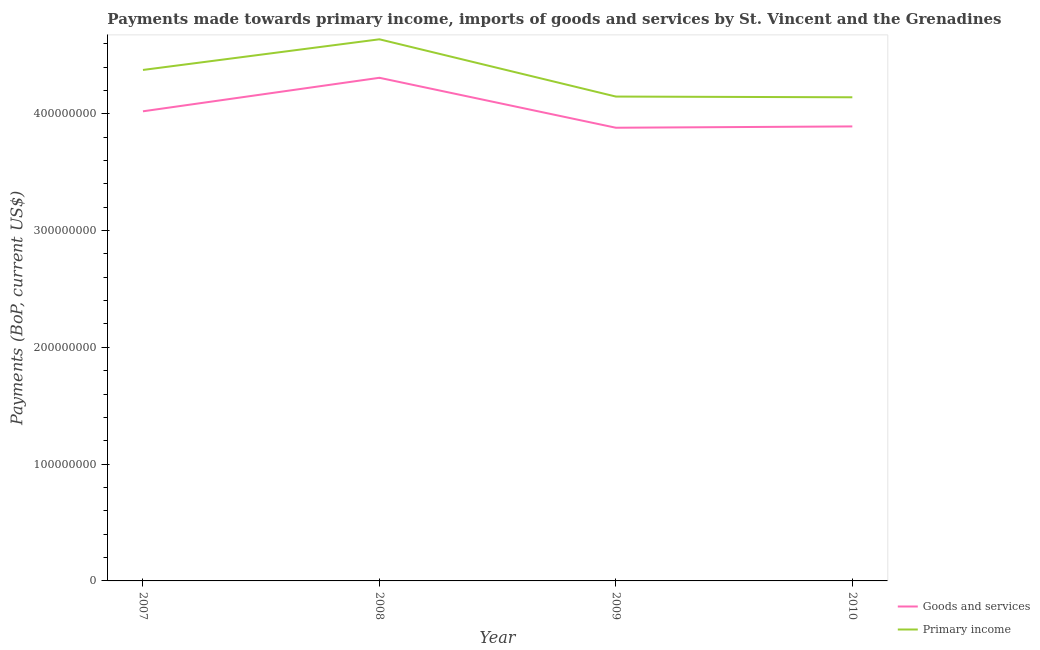How many different coloured lines are there?
Provide a succinct answer. 2. What is the payments made towards primary income in 2007?
Ensure brevity in your answer.  4.38e+08. Across all years, what is the maximum payments made towards primary income?
Give a very brief answer. 4.64e+08. Across all years, what is the minimum payments made towards primary income?
Give a very brief answer. 4.14e+08. In which year was the payments made towards goods and services maximum?
Provide a succinct answer. 2008. In which year was the payments made towards primary income minimum?
Provide a succinct answer. 2010. What is the total payments made towards primary income in the graph?
Provide a succinct answer. 1.73e+09. What is the difference between the payments made towards primary income in 2009 and that in 2010?
Give a very brief answer. 6.12e+05. What is the difference between the payments made towards primary income in 2009 and the payments made towards goods and services in 2008?
Provide a succinct answer. -1.61e+07. What is the average payments made towards goods and services per year?
Offer a very short reply. 4.03e+08. In the year 2007, what is the difference between the payments made towards goods and services and payments made towards primary income?
Ensure brevity in your answer.  -3.54e+07. What is the ratio of the payments made towards primary income in 2007 to that in 2008?
Offer a very short reply. 0.94. Is the payments made towards goods and services in 2007 less than that in 2010?
Give a very brief answer. No. Is the difference between the payments made towards primary income in 2008 and 2009 greater than the difference between the payments made towards goods and services in 2008 and 2009?
Ensure brevity in your answer.  Yes. What is the difference between the highest and the second highest payments made towards goods and services?
Offer a terse response. 2.87e+07. What is the difference between the highest and the lowest payments made towards primary income?
Ensure brevity in your answer.  4.96e+07. In how many years, is the payments made towards primary income greater than the average payments made towards primary income taken over all years?
Keep it short and to the point. 2. Is the sum of the payments made towards primary income in 2008 and 2009 greater than the maximum payments made towards goods and services across all years?
Your answer should be very brief. Yes. Does the payments made towards goods and services monotonically increase over the years?
Offer a terse response. No. Is the payments made towards primary income strictly greater than the payments made towards goods and services over the years?
Make the answer very short. Yes. Is the payments made towards goods and services strictly less than the payments made towards primary income over the years?
Keep it short and to the point. Yes. How many lines are there?
Provide a succinct answer. 2. How many years are there in the graph?
Keep it short and to the point. 4. Are the values on the major ticks of Y-axis written in scientific E-notation?
Your answer should be compact. No. Does the graph contain any zero values?
Give a very brief answer. No. Where does the legend appear in the graph?
Your answer should be very brief. Bottom right. How many legend labels are there?
Your answer should be compact. 2. What is the title of the graph?
Offer a very short reply. Payments made towards primary income, imports of goods and services by St. Vincent and the Grenadines. Does "Total Population" appear as one of the legend labels in the graph?
Your answer should be compact. No. What is the label or title of the Y-axis?
Make the answer very short. Payments (BoP, current US$). What is the Payments (BoP, current US$) of Goods and services in 2007?
Give a very brief answer. 4.02e+08. What is the Payments (BoP, current US$) of Primary income in 2007?
Provide a short and direct response. 4.38e+08. What is the Payments (BoP, current US$) in Goods and services in 2008?
Your answer should be compact. 4.31e+08. What is the Payments (BoP, current US$) of Primary income in 2008?
Offer a very short reply. 4.64e+08. What is the Payments (BoP, current US$) of Goods and services in 2009?
Provide a succinct answer. 3.88e+08. What is the Payments (BoP, current US$) of Primary income in 2009?
Give a very brief answer. 4.15e+08. What is the Payments (BoP, current US$) of Goods and services in 2010?
Provide a short and direct response. 3.89e+08. What is the Payments (BoP, current US$) in Primary income in 2010?
Offer a terse response. 4.14e+08. Across all years, what is the maximum Payments (BoP, current US$) of Goods and services?
Ensure brevity in your answer.  4.31e+08. Across all years, what is the maximum Payments (BoP, current US$) in Primary income?
Your answer should be very brief. 4.64e+08. Across all years, what is the minimum Payments (BoP, current US$) in Goods and services?
Keep it short and to the point. 3.88e+08. Across all years, what is the minimum Payments (BoP, current US$) in Primary income?
Make the answer very short. 4.14e+08. What is the total Payments (BoP, current US$) in Goods and services in the graph?
Provide a succinct answer. 1.61e+09. What is the total Payments (BoP, current US$) of Primary income in the graph?
Make the answer very short. 1.73e+09. What is the difference between the Payments (BoP, current US$) in Goods and services in 2007 and that in 2008?
Offer a terse response. -2.87e+07. What is the difference between the Payments (BoP, current US$) in Primary income in 2007 and that in 2008?
Offer a terse response. -2.62e+07. What is the difference between the Payments (BoP, current US$) of Goods and services in 2007 and that in 2009?
Offer a terse response. 1.41e+07. What is the difference between the Payments (BoP, current US$) in Primary income in 2007 and that in 2009?
Give a very brief answer. 2.28e+07. What is the difference between the Payments (BoP, current US$) in Goods and services in 2007 and that in 2010?
Provide a short and direct response. 1.29e+07. What is the difference between the Payments (BoP, current US$) of Primary income in 2007 and that in 2010?
Ensure brevity in your answer.  2.34e+07. What is the difference between the Payments (BoP, current US$) in Goods and services in 2008 and that in 2009?
Offer a very short reply. 4.28e+07. What is the difference between the Payments (BoP, current US$) in Primary income in 2008 and that in 2009?
Your answer should be compact. 4.90e+07. What is the difference between the Payments (BoP, current US$) in Goods and services in 2008 and that in 2010?
Make the answer very short. 4.16e+07. What is the difference between the Payments (BoP, current US$) in Primary income in 2008 and that in 2010?
Your answer should be compact. 4.96e+07. What is the difference between the Payments (BoP, current US$) in Goods and services in 2009 and that in 2010?
Keep it short and to the point. -1.13e+06. What is the difference between the Payments (BoP, current US$) in Primary income in 2009 and that in 2010?
Offer a terse response. 6.12e+05. What is the difference between the Payments (BoP, current US$) in Goods and services in 2007 and the Payments (BoP, current US$) in Primary income in 2008?
Provide a short and direct response. -6.17e+07. What is the difference between the Payments (BoP, current US$) in Goods and services in 2007 and the Payments (BoP, current US$) in Primary income in 2009?
Provide a short and direct response. -1.26e+07. What is the difference between the Payments (BoP, current US$) of Goods and services in 2007 and the Payments (BoP, current US$) of Primary income in 2010?
Keep it short and to the point. -1.20e+07. What is the difference between the Payments (BoP, current US$) of Goods and services in 2008 and the Payments (BoP, current US$) of Primary income in 2009?
Ensure brevity in your answer.  1.61e+07. What is the difference between the Payments (BoP, current US$) in Goods and services in 2008 and the Payments (BoP, current US$) in Primary income in 2010?
Ensure brevity in your answer.  1.67e+07. What is the difference between the Payments (BoP, current US$) in Goods and services in 2009 and the Payments (BoP, current US$) in Primary income in 2010?
Offer a very short reply. -2.61e+07. What is the average Payments (BoP, current US$) of Goods and services per year?
Your answer should be very brief. 4.03e+08. What is the average Payments (BoP, current US$) in Primary income per year?
Provide a succinct answer. 4.33e+08. In the year 2007, what is the difference between the Payments (BoP, current US$) in Goods and services and Payments (BoP, current US$) in Primary income?
Offer a terse response. -3.54e+07. In the year 2008, what is the difference between the Payments (BoP, current US$) in Goods and services and Payments (BoP, current US$) in Primary income?
Make the answer very short. -3.30e+07. In the year 2009, what is the difference between the Payments (BoP, current US$) of Goods and services and Payments (BoP, current US$) of Primary income?
Offer a very short reply. -2.67e+07. In the year 2010, what is the difference between the Payments (BoP, current US$) of Goods and services and Payments (BoP, current US$) of Primary income?
Offer a terse response. -2.49e+07. What is the ratio of the Payments (BoP, current US$) in Goods and services in 2007 to that in 2008?
Make the answer very short. 0.93. What is the ratio of the Payments (BoP, current US$) in Primary income in 2007 to that in 2008?
Your response must be concise. 0.94. What is the ratio of the Payments (BoP, current US$) of Goods and services in 2007 to that in 2009?
Give a very brief answer. 1.04. What is the ratio of the Payments (BoP, current US$) in Primary income in 2007 to that in 2009?
Ensure brevity in your answer.  1.05. What is the ratio of the Payments (BoP, current US$) of Goods and services in 2007 to that in 2010?
Offer a terse response. 1.03. What is the ratio of the Payments (BoP, current US$) in Primary income in 2007 to that in 2010?
Keep it short and to the point. 1.06. What is the ratio of the Payments (BoP, current US$) of Goods and services in 2008 to that in 2009?
Your answer should be compact. 1.11. What is the ratio of the Payments (BoP, current US$) in Primary income in 2008 to that in 2009?
Offer a terse response. 1.12. What is the ratio of the Payments (BoP, current US$) in Goods and services in 2008 to that in 2010?
Make the answer very short. 1.11. What is the ratio of the Payments (BoP, current US$) in Primary income in 2008 to that in 2010?
Your answer should be very brief. 1.12. What is the ratio of the Payments (BoP, current US$) in Goods and services in 2009 to that in 2010?
Your answer should be very brief. 1. What is the ratio of the Payments (BoP, current US$) of Primary income in 2009 to that in 2010?
Your answer should be compact. 1. What is the difference between the highest and the second highest Payments (BoP, current US$) of Goods and services?
Provide a succinct answer. 2.87e+07. What is the difference between the highest and the second highest Payments (BoP, current US$) in Primary income?
Keep it short and to the point. 2.62e+07. What is the difference between the highest and the lowest Payments (BoP, current US$) of Goods and services?
Make the answer very short. 4.28e+07. What is the difference between the highest and the lowest Payments (BoP, current US$) of Primary income?
Offer a terse response. 4.96e+07. 